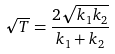Convert formula to latex. <formula><loc_0><loc_0><loc_500><loc_500>\sqrt { T } = \frac { 2 \sqrt { k _ { 1 } k _ { 2 } } } { k _ { 1 } + k _ { 2 } }</formula> 